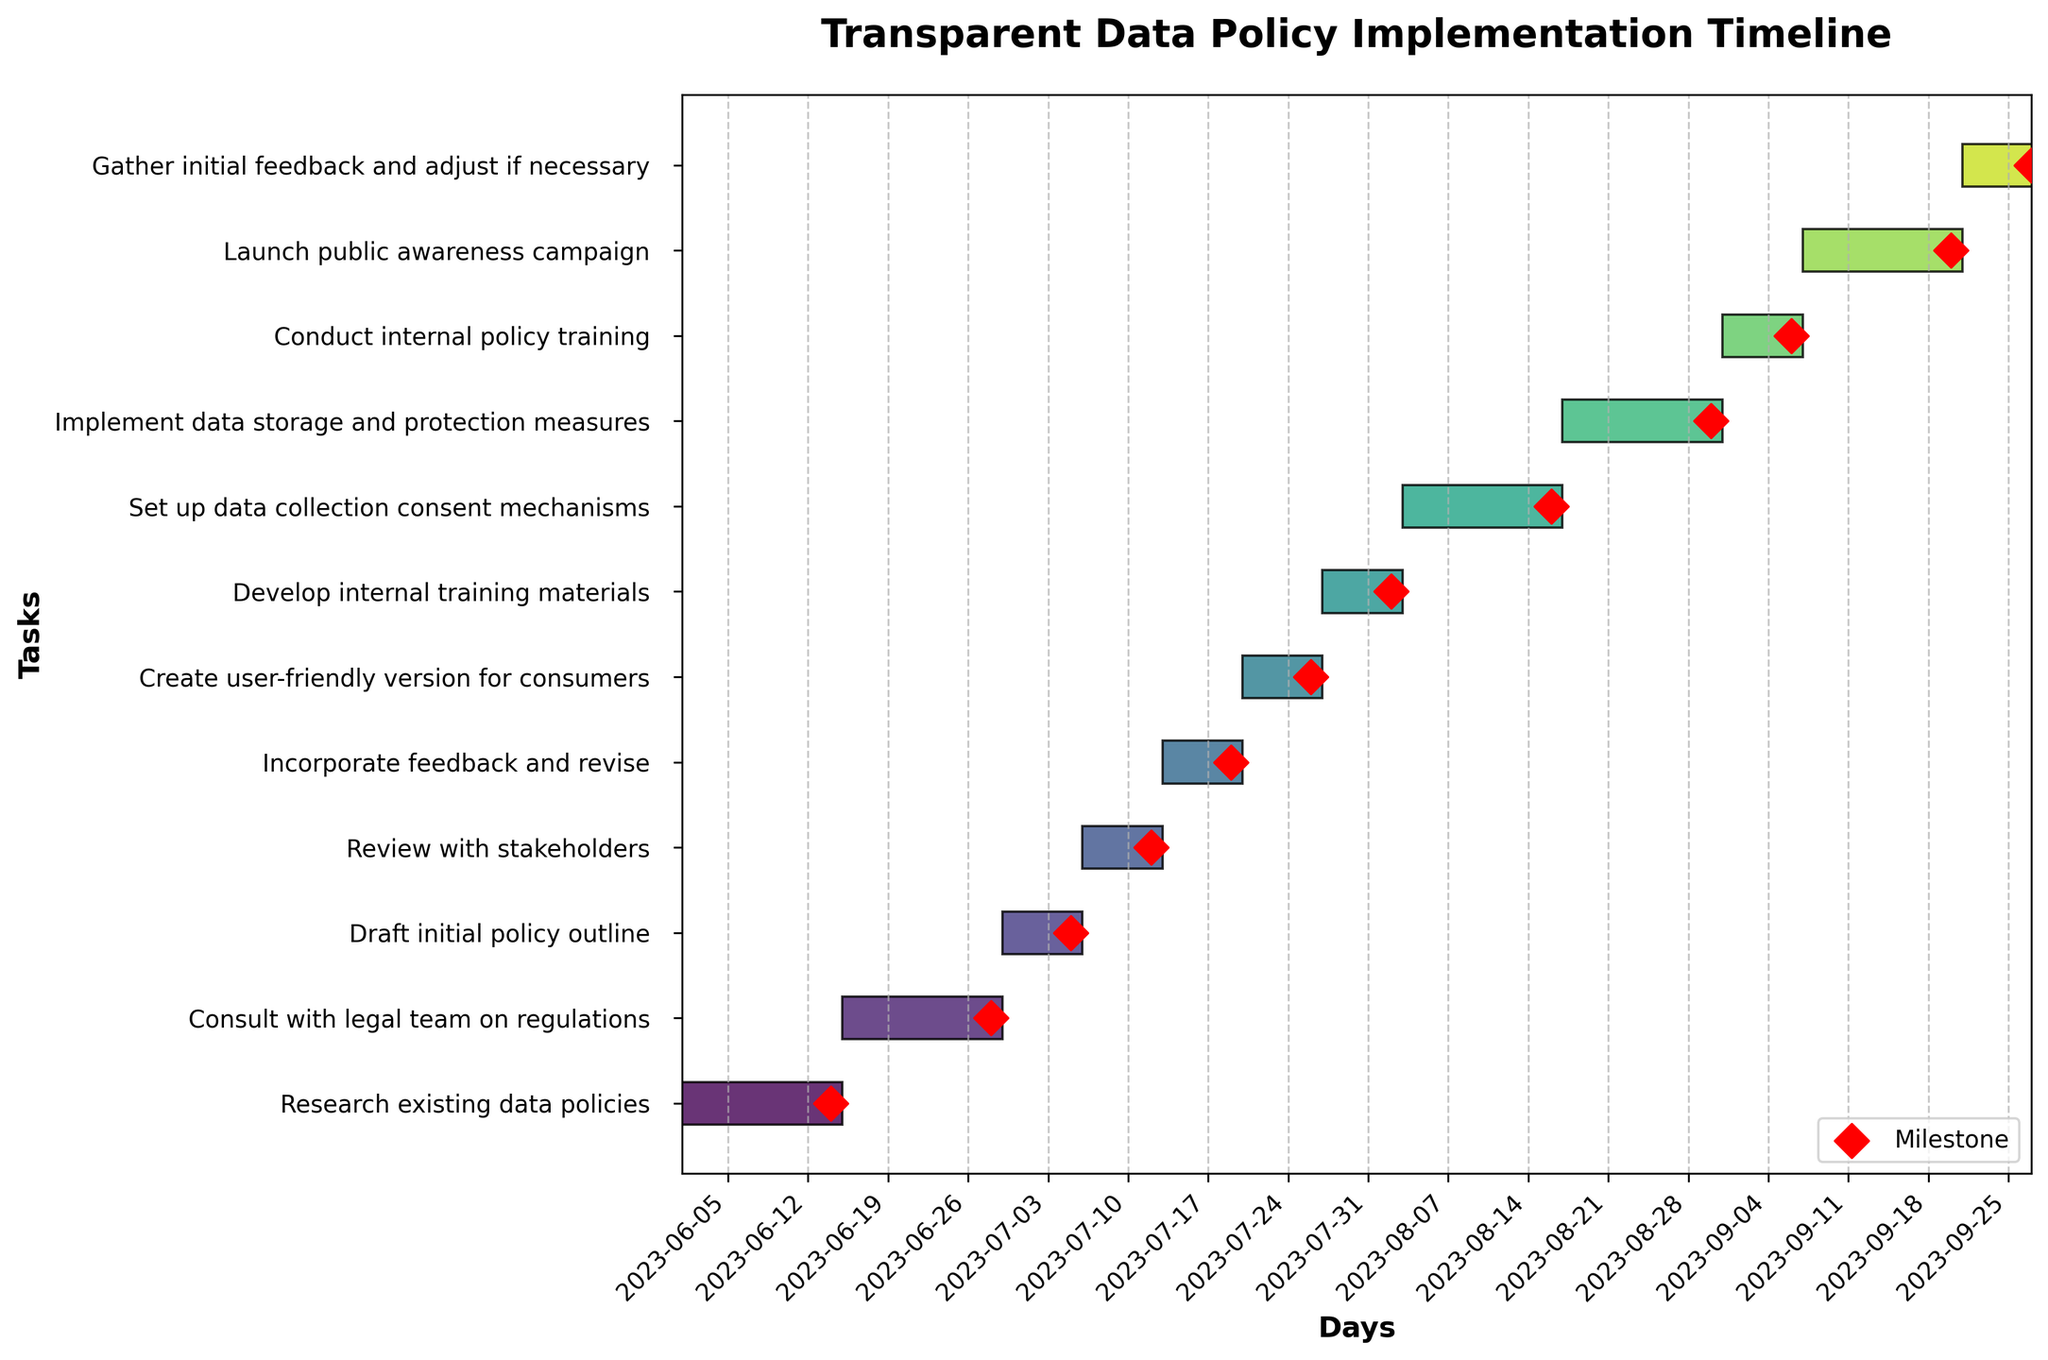What is the title of the Gantt chart? The title is typically located at the top of the chart, and it provides a brief summary of what the chart represents. In this case, it states "Transparent Data Policy Implementation Timeline".
Answer: Transparent Data Policy Implementation Timeline How many tasks are plotted on the Gantt chart? To find the number of tasks, count the horizontal bars, each of which corresponds to a task.
Answer: 12 Which task has the longest duration? By examining the lengths of the horizontal bars, you can see which bar is the longest. This corresponds to the task with the longest duration.
Answer: Set up data collection consent mechanisms and Implement data storage and protection measures What are the start and end dates for the task "Create user-friendly version for consumers"? Look directly at the left and right ends of the bar for this task, and check the x-axis labels corresponding to these points.
Answer: Start: 2023-07-20, End: 2023-07-26 Which task has the shortest duration, and what is its duration? Identify the shortest horizontal bar on the Gantt chart and read its corresponding duration from the labels or look up the task in the list of tasks.
Answer: Draft initial policy outline and Review with stakeholders, Duration: 7 days How many days does it take to complete the entire project? Calculate the difference between the start date of the first task and the end date of the last task using the x-axis or the task details provided. The project takes 119 days.
Answer: 119 days Which tasks involve stakeholders? Look for tasks that explicitly mention stakeholders in their titles.
Answer: Review with stakeholders and Gather initial feedback and adjust if necessary What comes immediately after "Consult with legal team on regulations"? Identify the bars sequentially to find the next task immediately following "Consult with legal team on regulations".
Answer: Draft initial policy outline How many tasks end before August 2023? Count the number of tasks whose right-end points (end dates) are before August 1, 2023. These can be visually inspected from the x-axis date labels.
Answer: 4 Which tasks overlap with each other in terms of duration? Examine the bars to see which bars (tasks) have overlapping periods along the x-axis.
Answer: - Incorporate feedback and revise overlaps with Create user-friendly version for consumers.
- Develop internal training materials overlaps with Set up data collection consent mechanisms.
- Implement data storage and protection measures overlaps with Conduct internal policy training 